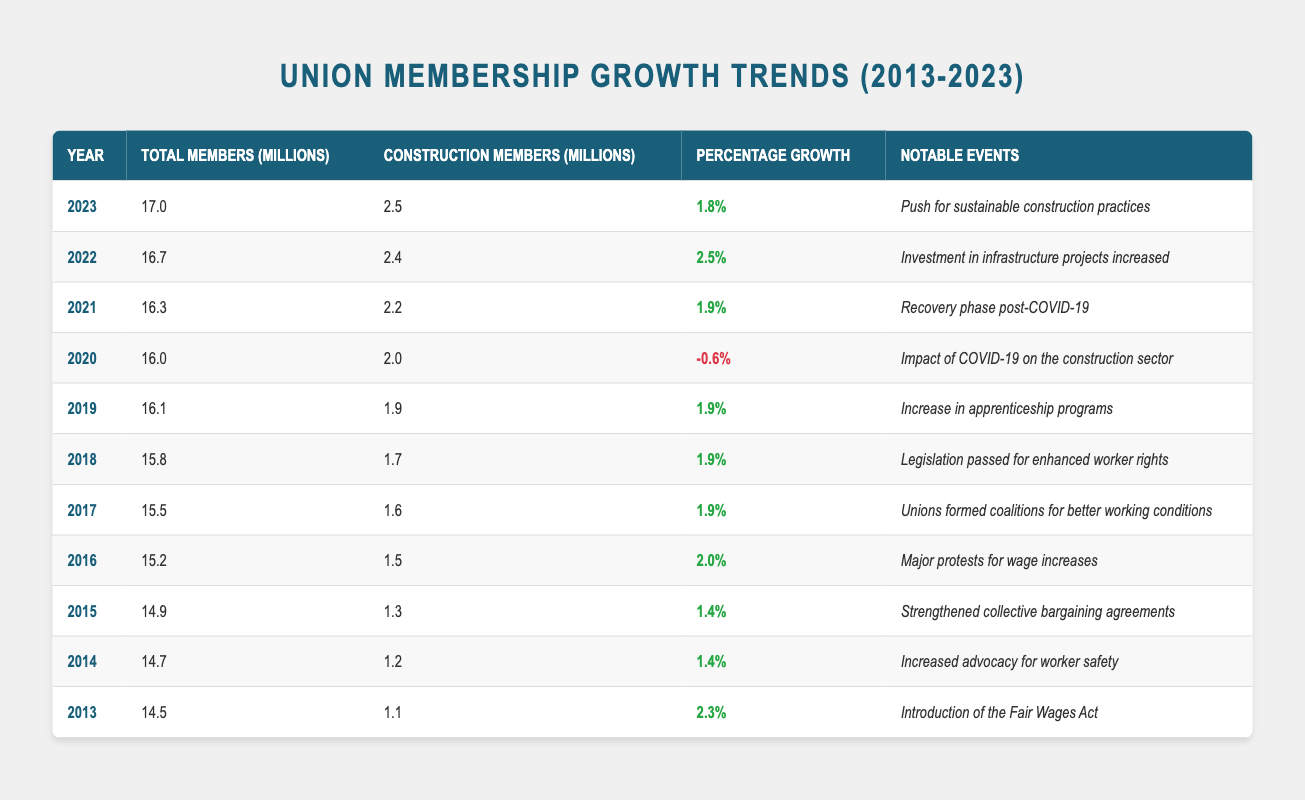What was the total number of construction members in 2020? In the year 2020, the table records a total of construction members as 2.0 million. This can be found directly in the row corresponding to the year 2020.
Answer: 2.0 million Which year had the highest percentage growth? The percentage growth of 2.5% in the year 2022 is the highest when compared to other years. This can be verified by scanning the column for percentage growth and finding the maximum value.
Answer: 2022 What is the total number of union members in the last three years (2021, 2022, 2023)? To find the total number of union members in the last three years, we sum the total members from each of those years: 16.3 + 16.7 + 17.0 = 50.0 million. Thus, the total is 50.0 million.
Answer: 50.0 million Did the number of construction members decrease in any year between 2013 and 2023? From the table, we see that the number of construction members decreased only in 2020, which remains at 2.0 million after having been 1.9 million in 2019. After 2020, construction members increased every year.
Answer: Yes How many years experienced a growth of more than 2%? We look at the percentage growth column and see that the years 2013 (2.3%), 2016 (2.0%), and 2022 (2.5%) had a growth of more than 2%. In total, there are three years.
Answer: 3 years In which year was there an impact on union membership due to a global event, and how much was the percentage change that year? The year that had an impact due to a global event was 2020, with the percentage change being -0.6%. This is noted as the impact of COVID-19 on the construction sector.
Answer: -0.6% What was the percentage growth for 2015, and how does it compare to the previous year? The percentage growth for 2015 was 1.4%. Compared to the previous year, 2014, which also had a growth of 1.4%, there was no difference in growth between the two years.
Answer: 1.4%, no difference What was the notable event in 2017, and how did it influence the membership growth in that year? The notable event in 2017 was the formation of coalitions by unions for better working conditions, which led to a percentage growth of 1.9%. This suggests that union activities contributed to relatively steady growth.
Answer: Formed coalitions, 1.9% growth What is the average total number of union members from 2013 to 2023? To calculate the average, we sum the total union members for each year from 2013 to 2023 (14.5 + 14.7 + 14.9 + 15.2 + 15.5 + 15.8 + 16.1 + 16.0 + 16.3 + 16.7 + 17.0 =  173.7 million), and divide this sum by the number of years, which is 11: 173.7 / 11 = 15.9 million.
Answer: 15.9 million 